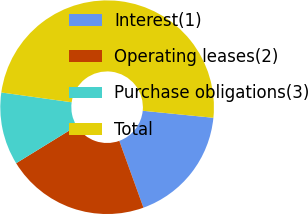Convert chart. <chart><loc_0><loc_0><loc_500><loc_500><pie_chart><fcel>Interest(1)<fcel>Operating leases(2)<fcel>Purchase obligations(3)<fcel>Total<nl><fcel>17.9%<fcel>21.74%<fcel>10.99%<fcel>49.38%<nl></chart> 